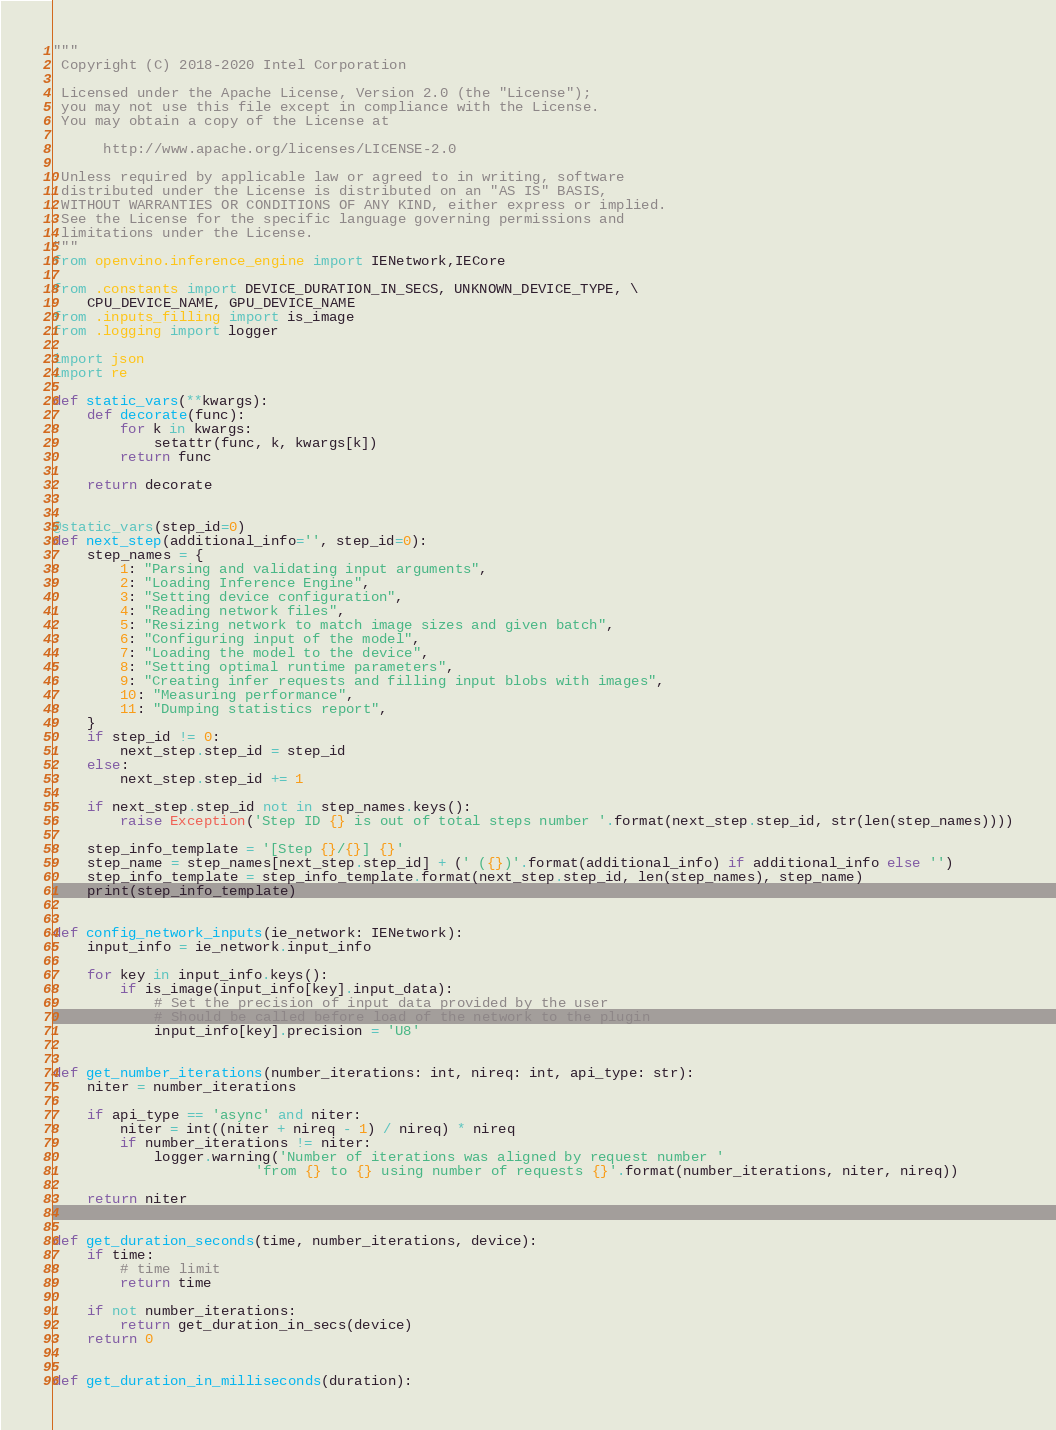<code> <loc_0><loc_0><loc_500><loc_500><_Python_>"""
 Copyright (C) 2018-2020 Intel Corporation

 Licensed under the Apache License, Version 2.0 (the "License");
 you may not use this file except in compliance with the License.
 You may obtain a copy of the License at

      http://www.apache.org/licenses/LICENSE-2.0

 Unless required by applicable law or agreed to in writing, software
 distributed under the License is distributed on an "AS IS" BASIS,
 WITHOUT WARRANTIES OR CONDITIONS OF ANY KIND, either express or implied.
 See the License for the specific language governing permissions and
 limitations under the License.
"""
from openvino.inference_engine import IENetwork,IECore

from .constants import DEVICE_DURATION_IN_SECS, UNKNOWN_DEVICE_TYPE, \
    CPU_DEVICE_NAME, GPU_DEVICE_NAME
from .inputs_filling import is_image
from .logging import logger

import json
import re

def static_vars(**kwargs):
    def decorate(func):
        for k in kwargs:
            setattr(func, k, kwargs[k])
        return func

    return decorate


@static_vars(step_id=0)
def next_step(additional_info='', step_id=0):
    step_names = {
        1: "Parsing and validating input arguments",
        2: "Loading Inference Engine",
        3: "Setting device configuration",
        4: "Reading network files",
        5: "Resizing network to match image sizes and given batch",
        6: "Configuring input of the model",
        7: "Loading the model to the device",
        8: "Setting optimal runtime parameters",
        9: "Creating infer requests and filling input blobs with images",
        10: "Measuring performance",
        11: "Dumping statistics report",
    }
    if step_id != 0:
        next_step.step_id = step_id
    else:
        next_step.step_id += 1

    if next_step.step_id not in step_names.keys():
        raise Exception('Step ID {} is out of total steps number '.format(next_step.step_id, str(len(step_names))))

    step_info_template = '[Step {}/{}] {}'
    step_name = step_names[next_step.step_id] + (' ({})'.format(additional_info) if additional_info else '')
    step_info_template = step_info_template.format(next_step.step_id, len(step_names), step_name)
    print(step_info_template)


def config_network_inputs(ie_network: IENetwork):
    input_info = ie_network.input_info

    for key in input_info.keys():
        if is_image(input_info[key].input_data):
            # Set the precision of input data provided by the user
            # Should be called before load of the network to the plugin
            input_info[key].precision = 'U8'


def get_number_iterations(number_iterations: int, nireq: int, api_type: str):
    niter = number_iterations

    if api_type == 'async' and niter:
        niter = int((niter + nireq - 1) / nireq) * nireq
        if number_iterations != niter:
            logger.warning('Number of iterations was aligned by request number '
                        'from {} to {} using number of requests {}'.format(number_iterations, niter, nireq))

    return niter


def get_duration_seconds(time, number_iterations, device):
    if time:
        # time limit
        return time

    if not number_iterations:
        return get_duration_in_secs(device)
    return 0


def get_duration_in_milliseconds(duration):</code> 